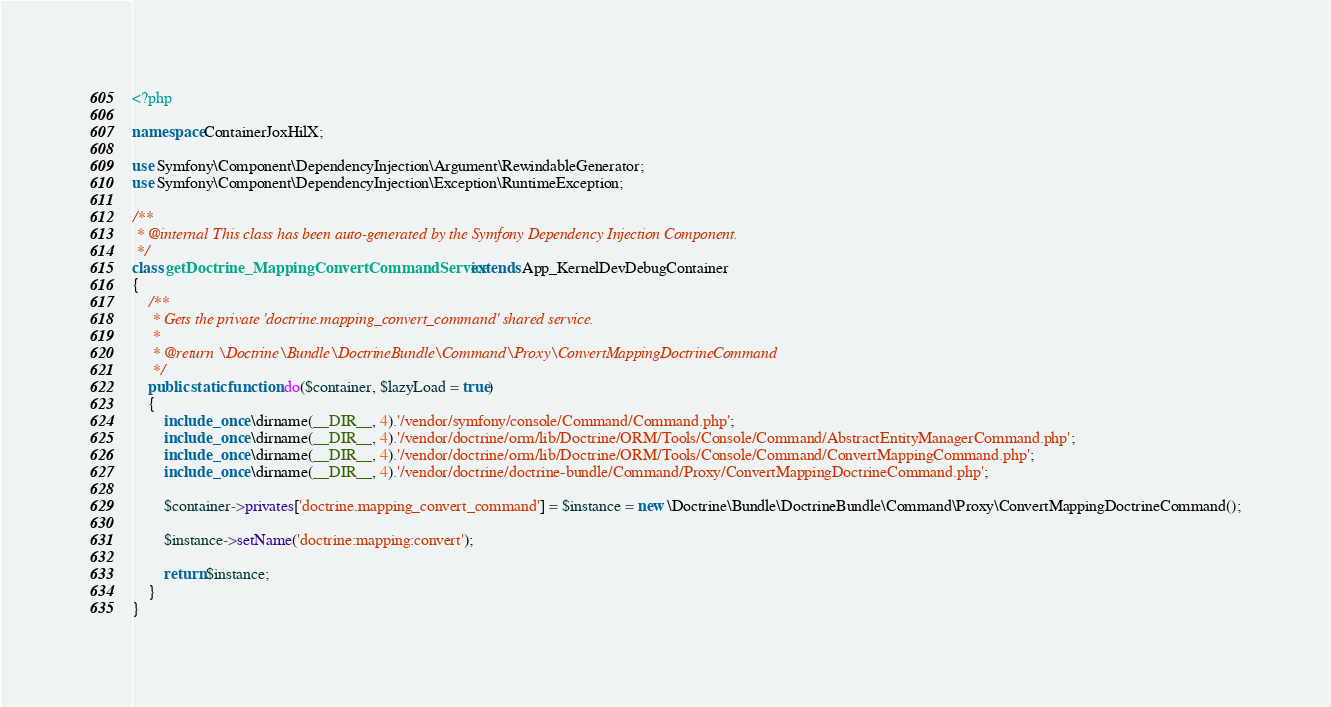<code> <loc_0><loc_0><loc_500><loc_500><_PHP_><?php

namespace ContainerJoxHilX;

use Symfony\Component\DependencyInjection\Argument\RewindableGenerator;
use Symfony\Component\DependencyInjection\Exception\RuntimeException;

/**
 * @internal This class has been auto-generated by the Symfony Dependency Injection Component.
 */
class getDoctrine_MappingConvertCommandService extends App_KernelDevDebugContainer
{
    /**
     * Gets the private 'doctrine.mapping_convert_command' shared service.
     *
     * @return \Doctrine\Bundle\DoctrineBundle\Command\Proxy\ConvertMappingDoctrineCommand
     */
    public static function do($container, $lazyLoad = true)
    {
        include_once \dirname(__DIR__, 4).'/vendor/symfony/console/Command/Command.php';
        include_once \dirname(__DIR__, 4).'/vendor/doctrine/orm/lib/Doctrine/ORM/Tools/Console/Command/AbstractEntityManagerCommand.php';
        include_once \dirname(__DIR__, 4).'/vendor/doctrine/orm/lib/Doctrine/ORM/Tools/Console/Command/ConvertMappingCommand.php';
        include_once \dirname(__DIR__, 4).'/vendor/doctrine/doctrine-bundle/Command/Proxy/ConvertMappingDoctrineCommand.php';

        $container->privates['doctrine.mapping_convert_command'] = $instance = new \Doctrine\Bundle\DoctrineBundle\Command\Proxy\ConvertMappingDoctrineCommand();

        $instance->setName('doctrine:mapping:convert');

        return $instance;
    }
}
</code> 